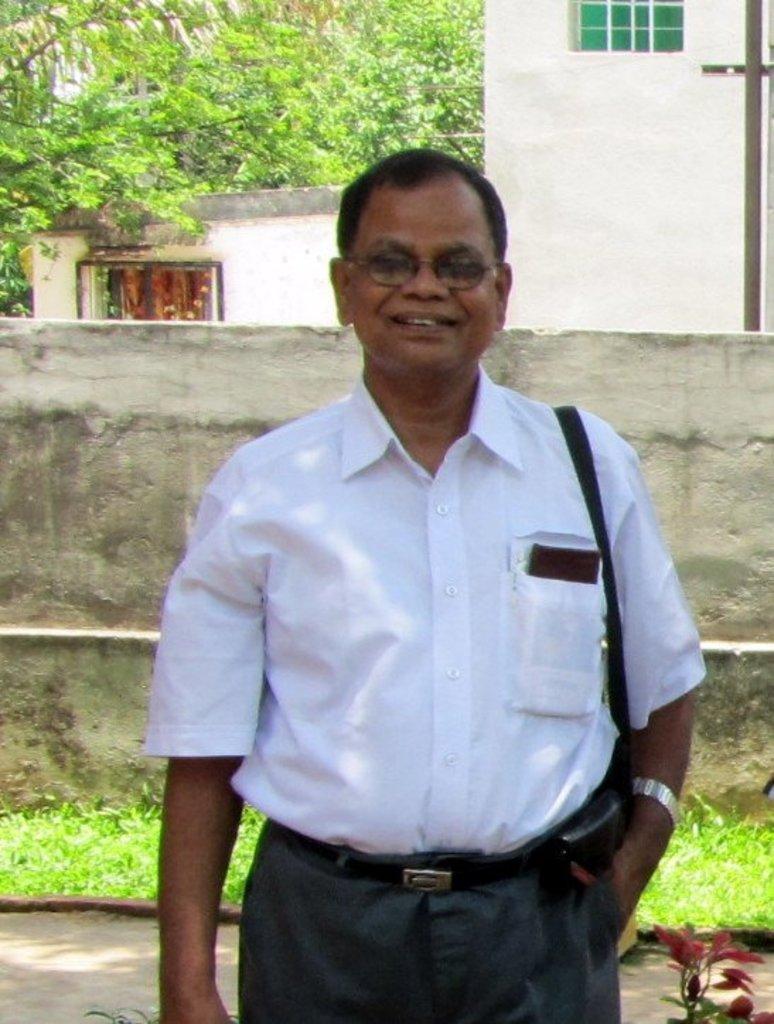Could you give a brief overview of what you see in this image? In this image I can see a person wearing a white color shirt and he is smiling and back side of him I can see building and the wall. 